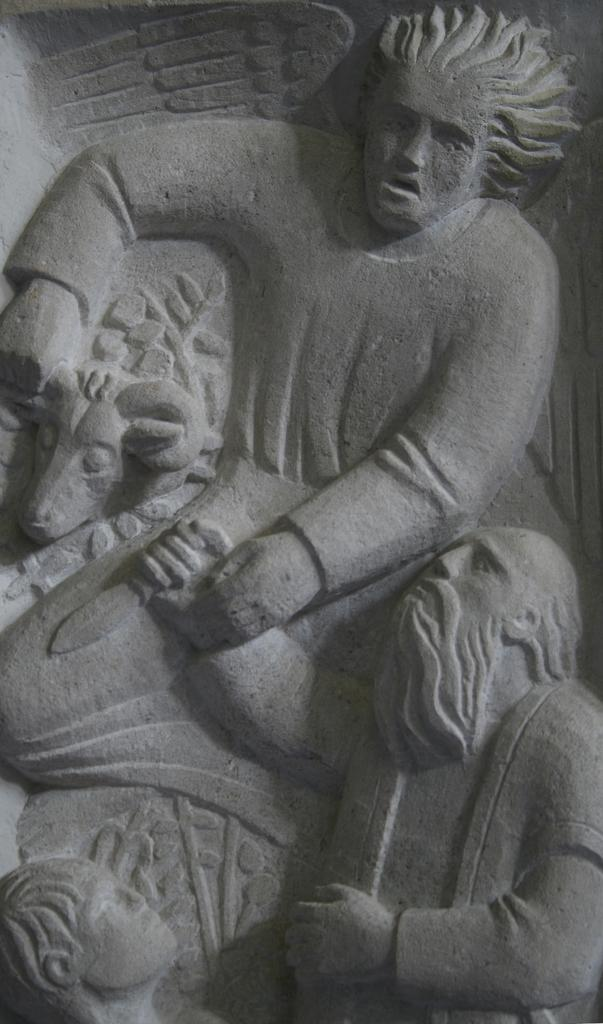What is the main subject of the image? There is a sculpture in the image. How many representatives are present in the image? There are no representatives present in the image; it features a sculpture. What type of horses can be seen interacting with the sculpture in the image? There are no horses present in the image; it features a sculpture. 